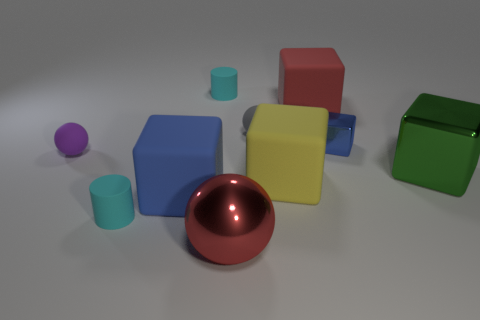There is a green cube that is the same size as the red cube; what is it made of?
Give a very brief answer. Metal. There is a cube behind the tiny gray sphere; what is its color?
Offer a terse response. Red. How many big green matte objects are there?
Make the answer very short. 0. Is there a big red cube that is left of the small cyan thing behind the big red thing that is behind the large red sphere?
Your response must be concise. No. What shape is the blue thing that is the same size as the yellow thing?
Provide a short and direct response. Cube. What number of other things are there of the same color as the large metal block?
Make the answer very short. 0. What is the material of the green block?
Keep it short and to the point. Metal. What number of other objects are the same material as the small cube?
Provide a short and direct response. 2. There is a sphere that is to the right of the purple thing and behind the big green block; what is its size?
Offer a terse response. Small. The cyan rubber object on the right side of the small cyan matte thing in front of the small purple object is what shape?
Provide a succinct answer. Cylinder. 